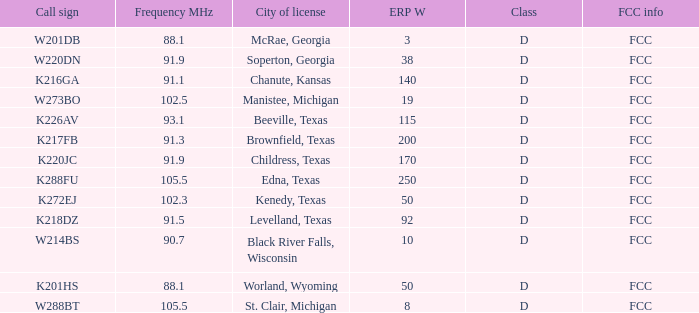When the call sign is k216ga, what is the erp w's sum? 140.0. 